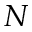Convert formula to latex. <formula><loc_0><loc_0><loc_500><loc_500>N</formula> 